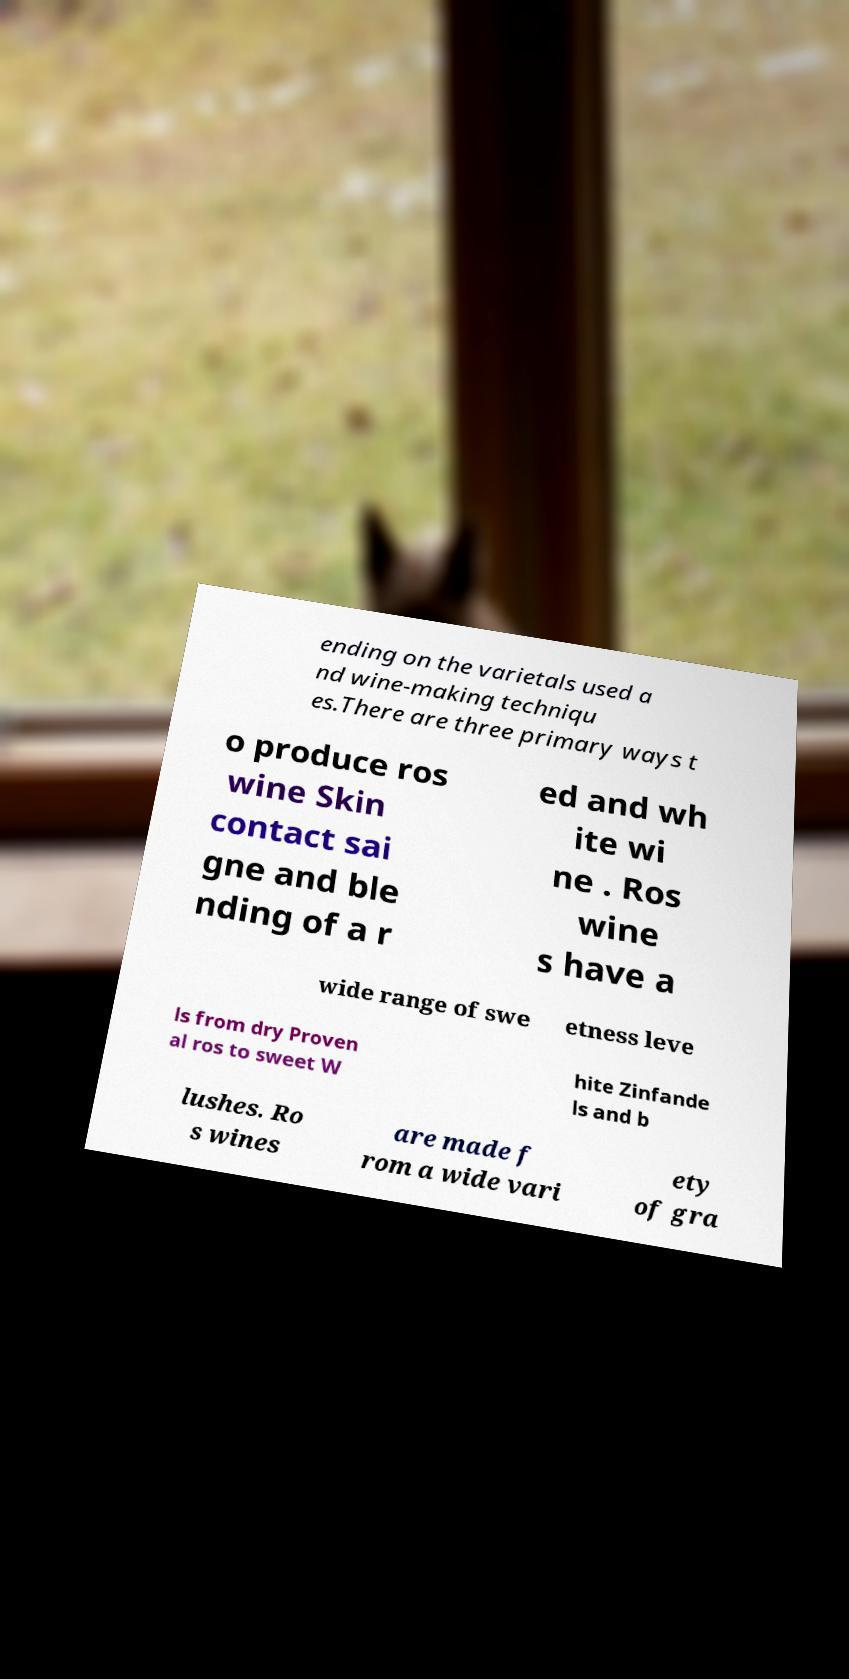I need the written content from this picture converted into text. Can you do that? ending on the varietals used a nd wine-making techniqu es.There are three primary ways t o produce ros wine Skin contact sai gne and ble nding of a r ed and wh ite wi ne . Ros wine s have a wide range of swe etness leve ls from dry Proven al ros to sweet W hite Zinfande ls and b lushes. Ro s wines are made f rom a wide vari ety of gra 